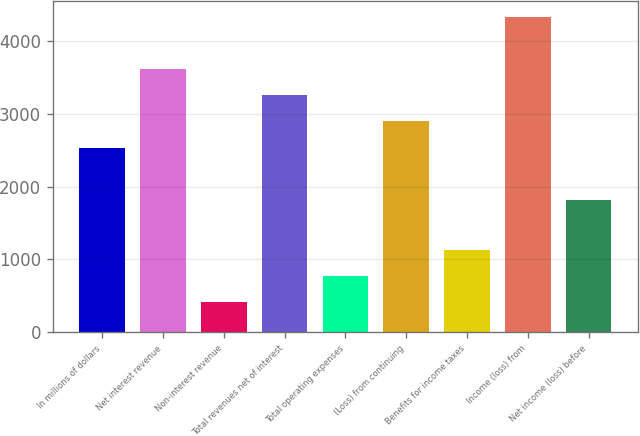Convert chart. <chart><loc_0><loc_0><loc_500><loc_500><bar_chart><fcel>In millions of dollars<fcel>Net interest revenue<fcel>Non-interest revenue<fcel>Total revenues net of interest<fcel>Total operating expenses<fcel>(Loss) from continuing<fcel>Benefits for income taxes<fcel>Income (loss) from<fcel>Net income (loss) before<nl><fcel>2535.8<fcel>3612.5<fcel>413<fcel>3253.6<fcel>771.9<fcel>2894.7<fcel>1130.8<fcel>4330.3<fcel>1818<nl></chart> 